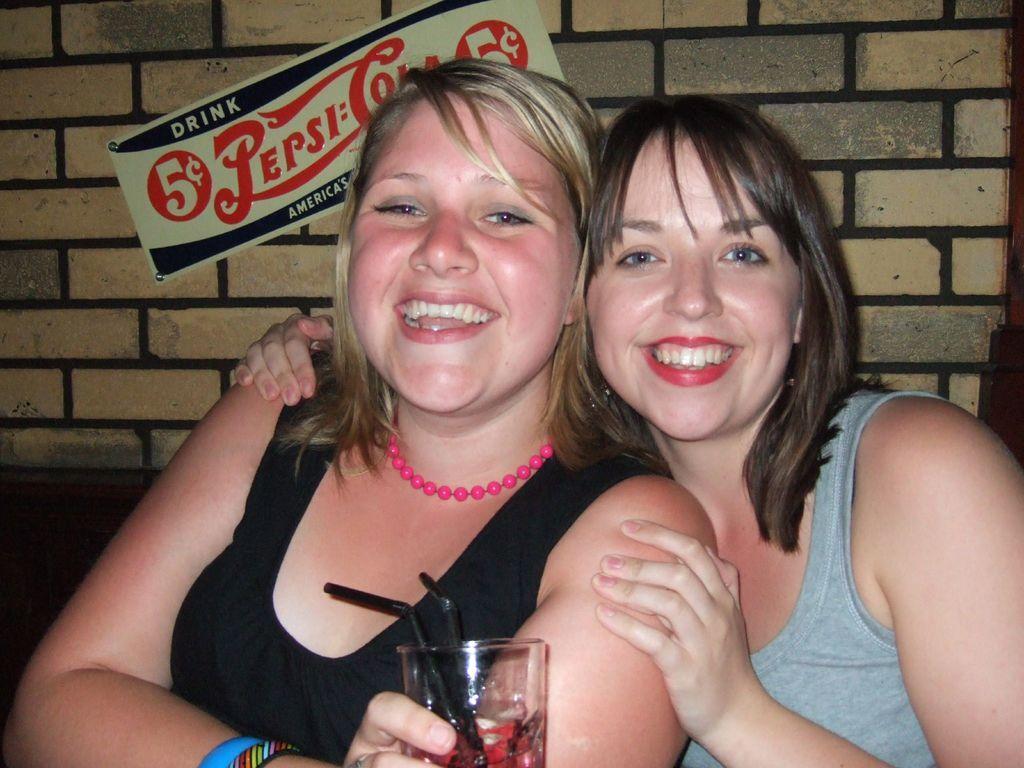In one or two sentences, can you explain what this image depicts? In this image I can see two people are smiling and one person is holding the glass. Back I can see a board is attached to the wall. 